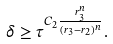<formula> <loc_0><loc_0><loc_500><loc_500>\delta \geq \tau ^ { C _ { 2 } \frac { r _ { 3 } ^ { n } } { ( r _ { 3 } - r _ { 2 } ) ^ { n } } } .</formula> 